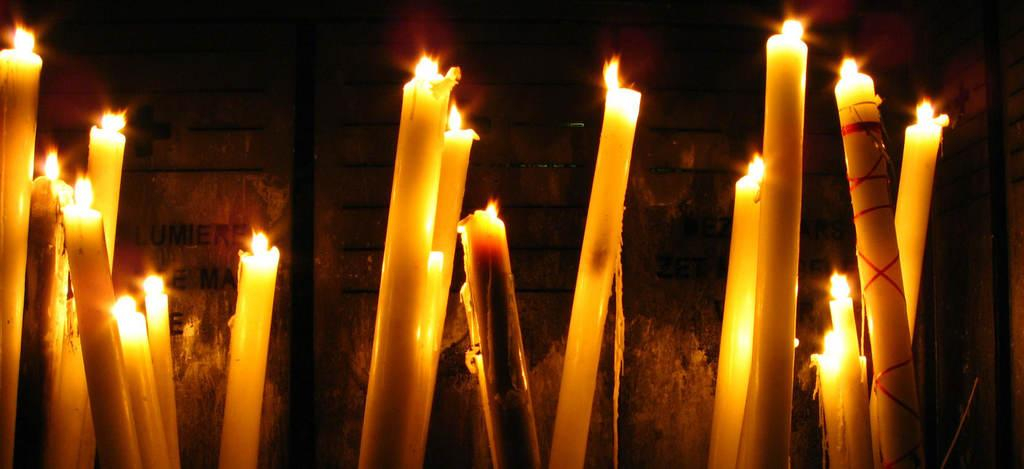What is burning in the image? There are candles with flames in the image. What type of structure can be seen in the background? There is a wall visible in the image. Is there any writing or symbols on the wall? Yes, there is some text on the wall. How many wings are visible on the candles in the image? There are no wings visible on the candles in the image. 